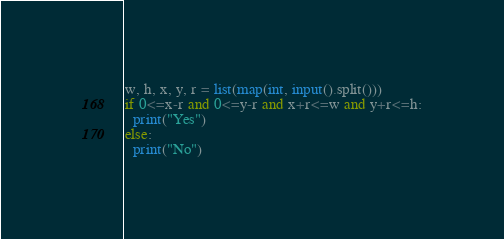Convert code to text. <code><loc_0><loc_0><loc_500><loc_500><_Python_>w, h, x, y, r = list(map(int, input().split()))
if 0<=x-r and 0<=y-r and x+r<=w and y+r<=h:
  print("Yes")
else:
  print("No")
</code> 